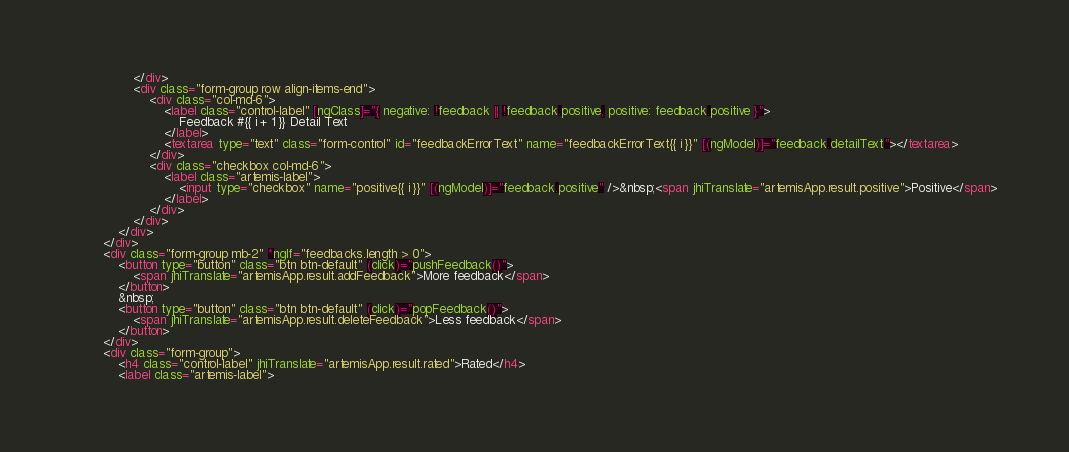Convert code to text. <code><loc_0><loc_0><loc_500><loc_500><_HTML_>                </div>
                <div class="form-group row align-items-end">
                    <div class="col-md-6">
                        <label class="control-label" [ngClass]="{ negative: !feedback || !feedback.positive, positive: feedback.positive }">
                            Feedback #{{ i + 1 }} Detail Text
                        </label>
                        <textarea type="text" class="form-control" id="feedbackErrorText" name="feedbackErrorText{{ i }}" [(ngModel)]="feedback.detailText"></textarea>
                    </div>
                    <div class="checkbox col-md-6">
                        <label class="artemis-label">
                            <input type="checkbox" name="positive{{ i }}" [(ngModel)]="feedback.positive" />&nbsp;<span jhiTranslate="artemisApp.result.positive">Positive</span>
                        </label>
                    </div>
                </div>
            </div>
        </div>
        <div class="form-group mb-2" *ngIf="feedbacks.length > 0">
            <button type="button" class="btn btn-default" (click)="pushFeedback()">
                <span jhiTranslate="artemisApp.result.addFeedback">More feedback</span>
            </button>
            &nbsp;
            <button type="button" class="btn btn-default" (click)="popFeedback()">
                <span jhiTranslate="artemisApp.result.deleteFeedback">Less feedback</span>
            </button>
        </div>
        <div class="form-group">
            <h4 class="control-label" jhiTranslate="artemisApp.result.rated">Rated</h4>
            <label class="artemis-label"></code> 